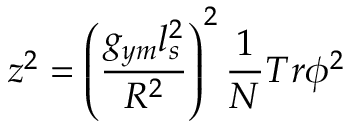Convert formula to latex. <formula><loc_0><loc_0><loc_500><loc_500>z ^ { 2 } = \left ( { \frac { g _ { y m } l _ { s } ^ { 2 } } { R ^ { 2 } } } \right ) ^ { 2 } { \frac { 1 } { N } } T r { \phi } ^ { 2 }</formula> 